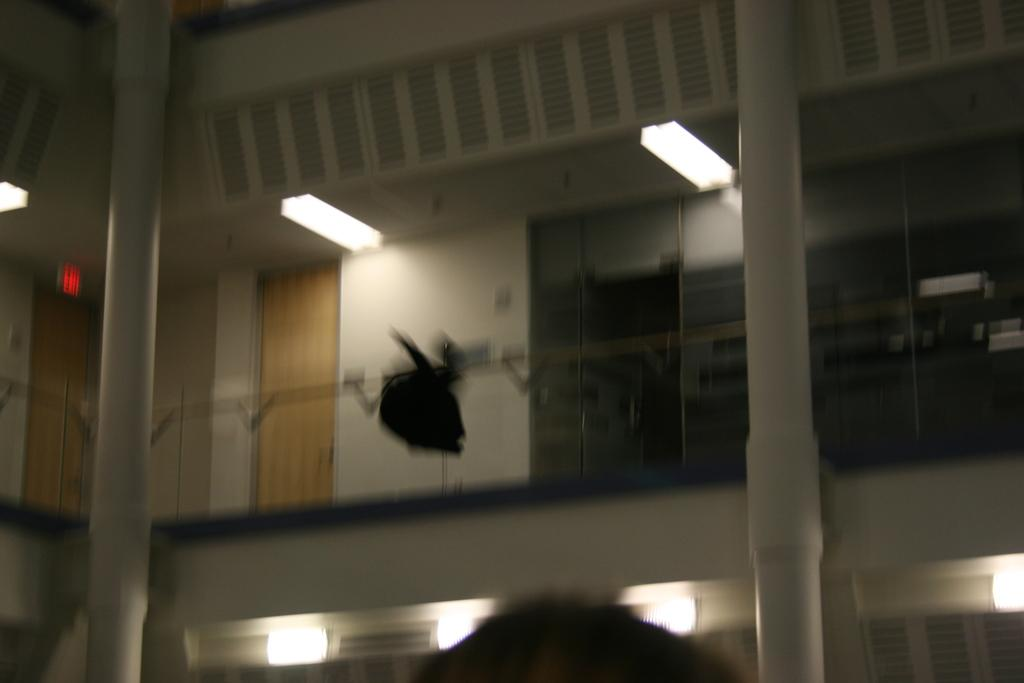What type of structure is shown in the image? The image depicts a building. What are some features of the building? There are doors, lights on the ceiling, glass doors, and pillars in the building. Can you describe the lighting in the building? The lights on the ceiling provide illumination in the building. What other objects can be seen in the building? There are other objects present in the building, but their specific details are not mentioned in the provided facts. Where is the boy playing with a car and basket in the image? There is no boy, car, or basket present in the image; it only shows a building with various features. 